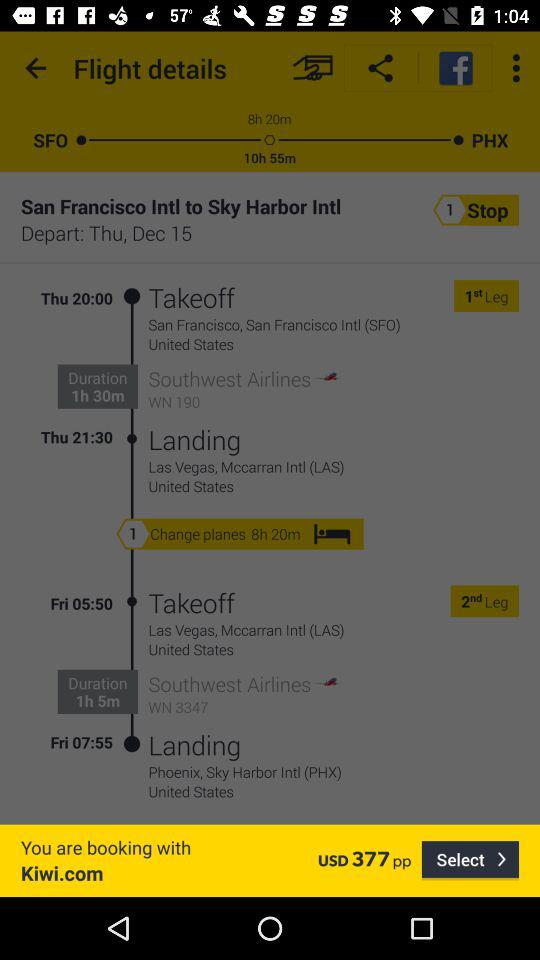What is the takeoff location of Southwest Airlines WN 190? The takeoff location is San Francisco, San Francisco Intl (SFO), United States. 